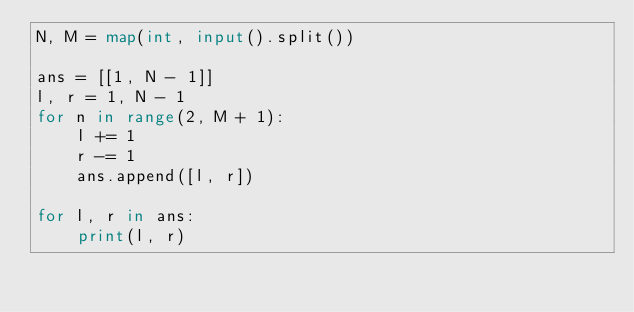Convert code to text. <code><loc_0><loc_0><loc_500><loc_500><_Python_>N, M = map(int, input().split())

ans = [[1, N - 1]]
l, r = 1, N - 1
for n in range(2, M + 1):
    l += 1
    r -= 1
    ans.append([l, r])

for l, r in ans:
    print(l, r)
</code> 